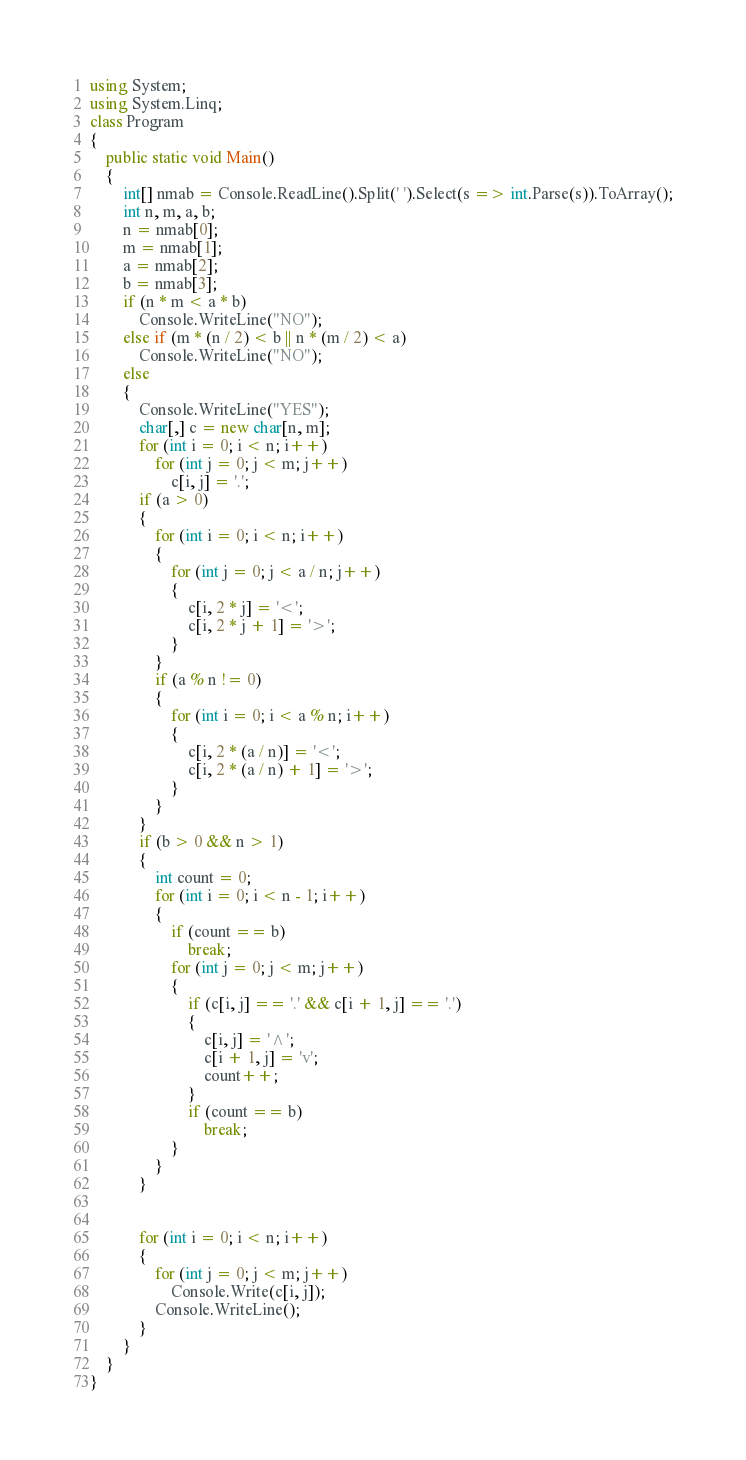<code> <loc_0><loc_0><loc_500><loc_500><_C#_>using System;
using System.Linq;
class Program
{
    public static void Main()
    {
        int[] nmab = Console.ReadLine().Split(' ').Select(s => int.Parse(s)).ToArray();
        int n, m, a, b;
        n = nmab[0];
        m = nmab[1];
        a = nmab[2];
        b = nmab[3];
        if (n * m < a * b)
            Console.WriteLine("NO");
        else if (m * (n / 2) < b || n * (m / 2) < a)
            Console.WriteLine("NO");
        else
        {
            Console.WriteLine("YES");
            char[,] c = new char[n, m];
            for (int i = 0; i < n; i++)
                for (int j = 0; j < m; j++)
                    c[i, j] = '.';
            if (a > 0)
            {
                for (int i = 0; i < n; i++)
                {
                    for (int j = 0; j < a / n; j++)
                    {
                        c[i, 2 * j] = '<';
                        c[i, 2 * j + 1] = '>';
                    }
                }
                if (a % n != 0)
                {
                    for (int i = 0; i < a % n; i++)
                    {
                        c[i, 2 * (a / n)] = '<';
                        c[i, 2 * (a / n) + 1] = '>';
                    }
                }
            }
            if (b > 0 && n > 1)
            {
                int count = 0;
                for (int i = 0; i < n - 1; i++)
                {
                    if (count == b)
                        break;
                    for (int j = 0; j < m; j++)
                    {
                        if (c[i, j] == '.' && c[i + 1, j] == '.')
                        {
                            c[i, j] = '^';
                            c[i + 1, j] = 'v';
                            count++;
                        }
                        if (count == b)
                            break;
                    }
                }
            }


            for (int i = 0; i < n; i++)
            {
                for (int j = 0; j < m; j++)
                    Console.Write(c[i, j]);
                Console.WriteLine();
            }
        }
    }
}</code> 